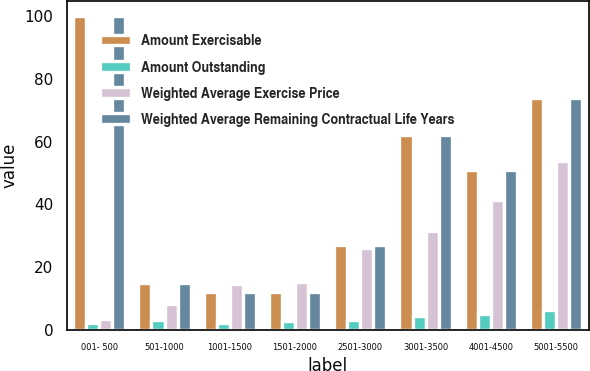<chart> <loc_0><loc_0><loc_500><loc_500><stacked_bar_chart><ecel><fcel>001- 500<fcel>501-1000<fcel>1001-1500<fcel>1501-2000<fcel>2501-3000<fcel>3001-3500<fcel>4001-4500<fcel>5001-5500<nl><fcel>Amount Exercisable<fcel>100<fcel>14.86<fcel>12<fcel>12<fcel>27<fcel>62<fcel>51<fcel>74<nl><fcel>Amount Outstanding<fcel>2.2<fcel>3.2<fcel>2.1<fcel>2.8<fcel>3.2<fcel>4.2<fcel>5.1<fcel>6.2<nl><fcel>Weighted Average Exercise Price<fcel>3.38<fcel>8.32<fcel>14.5<fcel>15.22<fcel>26.01<fcel>31.49<fcel>41.25<fcel>53.78<nl><fcel>Weighted Average Remaining Contractual Life Years<fcel>100<fcel>14.86<fcel>12<fcel>12<fcel>27<fcel>62<fcel>51<fcel>74<nl></chart> 